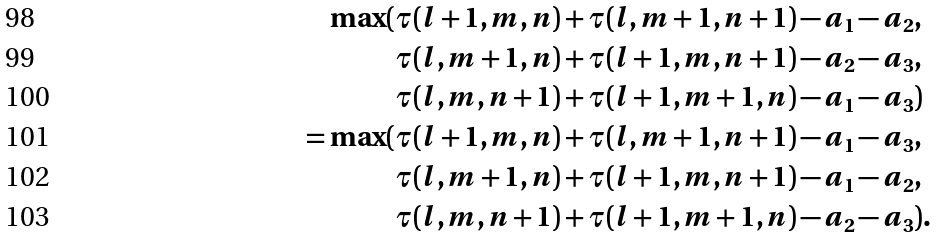<formula> <loc_0><loc_0><loc_500><loc_500>\max ( & \tau ( l + 1 , m , n ) + \tau ( l , m + 1 , n + 1 ) - a _ { 1 } - a _ { 2 } , \\ & \tau ( l , m + 1 , n ) + \tau ( l + 1 , m , n + 1 ) - a _ { 2 } - a _ { 3 } , \\ & \tau ( l , m , n + 1 ) + \tau ( l + 1 , m + 1 , n ) - a _ { 1 } - a _ { 3 } ) \\ = \max ( & \tau ( l + 1 , m , n ) + \tau ( l , m + 1 , n + 1 ) - a _ { 1 } - a _ { 3 } , \\ & \tau ( l , m + 1 , n ) + \tau ( l + 1 , m , n + 1 ) - a _ { 1 } - a _ { 2 } , \\ & \tau ( l , m , n + 1 ) + \tau ( l + 1 , m + 1 , n ) - a _ { 2 } - a _ { 3 } ) .</formula> 